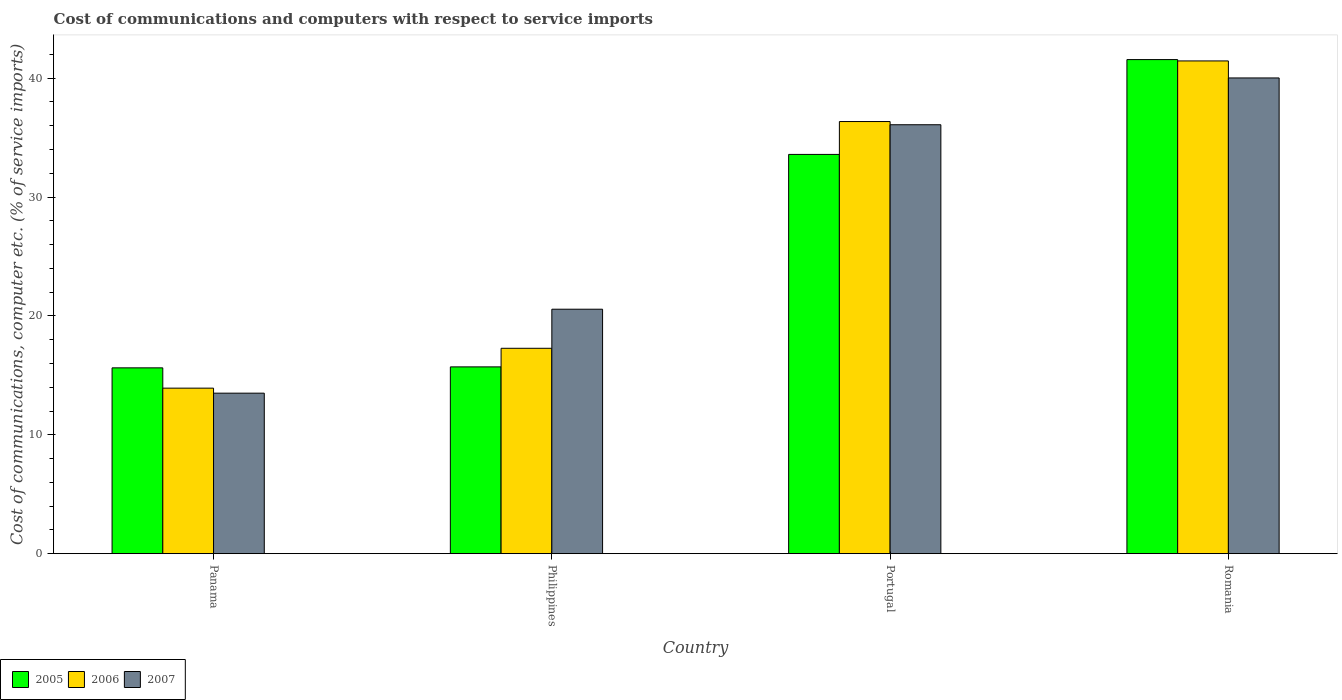How many bars are there on the 4th tick from the left?
Keep it short and to the point. 3. How many bars are there on the 4th tick from the right?
Offer a very short reply. 3. What is the label of the 4th group of bars from the left?
Offer a terse response. Romania. In how many cases, is the number of bars for a given country not equal to the number of legend labels?
Give a very brief answer. 0. What is the cost of communications and computers in 2006 in Philippines?
Your response must be concise. 17.28. Across all countries, what is the maximum cost of communications and computers in 2005?
Provide a short and direct response. 41.57. Across all countries, what is the minimum cost of communications and computers in 2007?
Your answer should be very brief. 13.5. In which country was the cost of communications and computers in 2007 maximum?
Ensure brevity in your answer.  Romania. In which country was the cost of communications and computers in 2007 minimum?
Provide a succinct answer. Panama. What is the total cost of communications and computers in 2006 in the graph?
Keep it short and to the point. 109.01. What is the difference between the cost of communications and computers in 2007 in Philippines and that in Portugal?
Give a very brief answer. -15.52. What is the difference between the cost of communications and computers in 2006 in Panama and the cost of communications and computers in 2007 in Portugal?
Your answer should be very brief. -22.16. What is the average cost of communications and computers in 2007 per country?
Provide a short and direct response. 27.54. What is the difference between the cost of communications and computers of/in 2005 and cost of communications and computers of/in 2007 in Philippines?
Your response must be concise. -4.85. In how many countries, is the cost of communications and computers in 2005 greater than 32 %?
Give a very brief answer. 2. What is the ratio of the cost of communications and computers in 2006 in Philippines to that in Portugal?
Give a very brief answer. 0.48. Is the cost of communications and computers in 2005 in Panama less than that in Philippines?
Give a very brief answer. Yes. What is the difference between the highest and the second highest cost of communications and computers in 2006?
Your answer should be very brief. 5.1. What is the difference between the highest and the lowest cost of communications and computers in 2005?
Give a very brief answer. 25.93. In how many countries, is the cost of communications and computers in 2007 greater than the average cost of communications and computers in 2007 taken over all countries?
Your answer should be very brief. 2. Is the sum of the cost of communications and computers in 2006 in Panama and Portugal greater than the maximum cost of communications and computers in 2005 across all countries?
Your response must be concise. Yes. What does the 2nd bar from the right in Philippines represents?
Offer a terse response. 2006. What is the difference between two consecutive major ticks on the Y-axis?
Provide a succinct answer. 10. Are the values on the major ticks of Y-axis written in scientific E-notation?
Make the answer very short. No. Does the graph contain any zero values?
Make the answer very short. No. Where does the legend appear in the graph?
Your answer should be compact. Bottom left. How many legend labels are there?
Provide a short and direct response. 3. What is the title of the graph?
Ensure brevity in your answer.  Cost of communications and computers with respect to service imports. What is the label or title of the Y-axis?
Your answer should be compact. Cost of communications, computer etc. (% of service imports). What is the Cost of communications, computer etc. (% of service imports) of 2005 in Panama?
Provide a short and direct response. 15.63. What is the Cost of communications, computer etc. (% of service imports) of 2006 in Panama?
Offer a terse response. 13.92. What is the Cost of communications, computer etc. (% of service imports) of 2007 in Panama?
Make the answer very short. 13.5. What is the Cost of communications, computer etc. (% of service imports) in 2005 in Philippines?
Ensure brevity in your answer.  15.71. What is the Cost of communications, computer etc. (% of service imports) in 2006 in Philippines?
Your answer should be very brief. 17.28. What is the Cost of communications, computer etc. (% of service imports) of 2007 in Philippines?
Make the answer very short. 20.57. What is the Cost of communications, computer etc. (% of service imports) of 2005 in Portugal?
Ensure brevity in your answer.  33.59. What is the Cost of communications, computer etc. (% of service imports) of 2006 in Portugal?
Provide a short and direct response. 36.35. What is the Cost of communications, computer etc. (% of service imports) in 2007 in Portugal?
Keep it short and to the point. 36.08. What is the Cost of communications, computer etc. (% of service imports) in 2005 in Romania?
Give a very brief answer. 41.57. What is the Cost of communications, computer etc. (% of service imports) of 2006 in Romania?
Provide a short and direct response. 41.45. What is the Cost of communications, computer etc. (% of service imports) of 2007 in Romania?
Provide a succinct answer. 40.02. Across all countries, what is the maximum Cost of communications, computer etc. (% of service imports) of 2005?
Provide a succinct answer. 41.57. Across all countries, what is the maximum Cost of communications, computer etc. (% of service imports) of 2006?
Provide a short and direct response. 41.45. Across all countries, what is the maximum Cost of communications, computer etc. (% of service imports) of 2007?
Give a very brief answer. 40.02. Across all countries, what is the minimum Cost of communications, computer etc. (% of service imports) of 2005?
Your response must be concise. 15.63. Across all countries, what is the minimum Cost of communications, computer etc. (% of service imports) in 2006?
Provide a short and direct response. 13.92. Across all countries, what is the minimum Cost of communications, computer etc. (% of service imports) of 2007?
Keep it short and to the point. 13.5. What is the total Cost of communications, computer etc. (% of service imports) in 2005 in the graph?
Keep it short and to the point. 106.5. What is the total Cost of communications, computer etc. (% of service imports) of 2006 in the graph?
Give a very brief answer. 109.01. What is the total Cost of communications, computer etc. (% of service imports) in 2007 in the graph?
Offer a very short reply. 110.17. What is the difference between the Cost of communications, computer etc. (% of service imports) in 2005 in Panama and that in Philippines?
Your answer should be very brief. -0.08. What is the difference between the Cost of communications, computer etc. (% of service imports) in 2006 in Panama and that in Philippines?
Ensure brevity in your answer.  -3.35. What is the difference between the Cost of communications, computer etc. (% of service imports) of 2007 in Panama and that in Philippines?
Your answer should be compact. -7.06. What is the difference between the Cost of communications, computer etc. (% of service imports) in 2005 in Panama and that in Portugal?
Give a very brief answer. -17.96. What is the difference between the Cost of communications, computer etc. (% of service imports) of 2006 in Panama and that in Portugal?
Your answer should be very brief. -22.43. What is the difference between the Cost of communications, computer etc. (% of service imports) of 2007 in Panama and that in Portugal?
Your answer should be compact. -22.58. What is the difference between the Cost of communications, computer etc. (% of service imports) in 2005 in Panama and that in Romania?
Your answer should be compact. -25.93. What is the difference between the Cost of communications, computer etc. (% of service imports) of 2006 in Panama and that in Romania?
Provide a short and direct response. -27.53. What is the difference between the Cost of communications, computer etc. (% of service imports) in 2007 in Panama and that in Romania?
Ensure brevity in your answer.  -26.52. What is the difference between the Cost of communications, computer etc. (% of service imports) of 2005 in Philippines and that in Portugal?
Ensure brevity in your answer.  -17.87. What is the difference between the Cost of communications, computer etc. (% of service imports) of 2006 in Philippines and that in Portugal?
Make the answer very short. -19.08. What is the difference between the Cost of communications, computer etc. (% of service imports) of 2007 in Philippines and that in Portugal?
Provide a succinct answer. -15.52. What is the difference between the Cost of communications, computer etc. (% of service imports) of 2005 in Philippines and that in Romania?
Give a very brief answer. -25.85. What is the difference between the Cost of communications, computer etc. (% of service imports) in 2006 in Philippines and that in Romania?
Your answer should be very brief. -24.18. What is the difference between the Cost of communications, computer etc. (% of service imports) in 2007 in Philippines and that in Romania?
Ensure brevity in your answer.  -19.45. What is the difference between the Cost of communications, computer etc. (% of service imports) in 2005 in Portugal and that in Romania?
Ensure brevity in your answer.  -7.98. What is the difference between the Cost of communications, computer etc. (% of service imports) of 2006 in Portugal and that in Romania?
Provide a short and direct response. -5.1. What is the difference between the Cost of communications, computer etc. (% of service imports) of 2007 in Portugal and that in Romania?
Offer a terse response. -3.94. What is the difference between the Cost of communications, computer etc. (% of service imports) of 2005 in Panama and the Cost of communications, computer etc. (% of service imports) of 2006 in Philippines?
Provide a succinct answer. -1.65. What is the difference between the Cost of communications, computer etc. (% of service imports) in 2005 in Panama and the Cost of communications, computer etc. (% of service imports) in 2007 in Philippines?
Provide a succinct answer. -4.93. What is the difference between the Cost of communications, computer etc. (% of service imports) of 2006 in Panama and the Cost of communications, computer etc. (% of service imports) of 2007 in Philippines?
Provide a succinct answer. -6.64. What is the difference between the Cost of communications, computer etc. (% of service imports) of 2005 in Panama and the Cost of communications, computer etc. (% of service imports) of 2006 in Portugal?
Offer a very short reply. -20.72. What is the difference between the Cost of communications, computer etc. (% of service imports) of 2005 in Panama and the Cost of communications, computer etc. (% of service imports) of 2007 in Portugal?
Your answer should be very brief. -20.45. What is the difference between the Cost of communications, computer etc. (% of service imports) of 2006 in Panama and the Cost of communications, computer etc. (% of service imports) of 2007 in Portugal?
Your response must be concise. -22.16. What is the difference between the Cost of communications, computer etc. (% of service imports) of 2005 in Panama and the Cost of communications, computer etc. (% of service imports) of 2006 in Romania?
Give a very brief answer. -25.82. What is the difference between the Cost of communications, computer etc. (% of service imports) in 2005 in Panama and the Cost of communications, computer etc. (% of service imports) in 2007 in Romania?
Provide a succinct answer. -24.39. What is the difference between the Cost of communications, computer etc. (% of service imports) in 2006 in Panama and the Cost of communications, computer etc. (% of service imports) in 2007 in Romania?
Provide a short and direct response. -26.1. What is the difference between the Cost of communications, computer etc. (% of service imports) of 2005 in Philippines and the Cost of communications, computer etc. (% of service imports) of 2006 in Portugal?
Your answer should be compact. -20.64. What is the difference between the Cost of communications, computer etc. (% of service imports) in 2005 in Philippines and the Cost of communications, computer etc. (% of service imports) in 2007 in Portugal?
Your answer should be very brief. -20.37. What is the difference between the Cost of communications, computer etc. (% of service imports) of 2006 in Philippines and the Cost of communications, computer etc. (% of service imports) of 2007 in Portugal?
Your answer should be very brief. -18.81. What is the difference between the Cost of communications, computer etc. (% of service imports) in 2005 in Philippines and the Cost of communications, computer etc. (% of service imports) in 2006 in Romania?
Give a very brief answer. -25.74. What is the difference between the Cost of communications, computer etc. (% of service imports) in 2005 in Philippines and the Cost of communications, computer etc. (% of service imports) in 2007 in Romania?
Offer a very short reply. -24.31. What is the difference between the Cost of communications, computer etc. (% of service imports) in 2006 in Philippines and the Cost of communications, computer etc. (% of service imports) in 2007 in Romania?
Provide a short and direct response. -22.74. What is the difference between the Cost of communications, computer etc. (% of service imports) of 2005 in Portugal and the Cost of communications, computer etc. (% of service imports) of 2006 in Romania?
Ensure brevity in your answer.  -7.86. What is the difference between the Cost of communications, computer etc. (% of service imports) in 2005 in Portugal and the Cost of communications, computer etc. (% of service imports) in 2007 in Romania?
Offer a terse response. -6.43. What is the difference between the Cost of communications, computer etc. (% of service imports) in 2006 in Portugal and the Cost of communications, computer etc. (% of service imports) in 2007 in Romania?
Offer a terse response. -3.67. What is the average Cost of communications, computer etc. (% of service imports) in 2005 per country?
Offer a very short reply. 26.62. What is the average Cost of communications, computer etc. (% of service imports) of 2006 per country?
Your answer should be very brief. 27.25. What is the average Cost of communications, computer etc. (% of service imports) of 2007 per country?
Make the answer very short. 27.54. What is the difference between the Cost of communications, computer etc. (% of service imports) of 2005 and Cost of communications, computer etc. (% of service imports) of 2006 in Panama?
Your response must be concise. 1.71. What is the difference between the Cost of communications, computer etc. (% of service imports) of 2005 and Cost of communications, computer etc. (% of service imports) of 2007 in Panama?
Your answer should be very brief. 2.13. What is the difference between the Cost of communications, computer etc. (% of service imports) of 2006 and Cost of communications, computer etc. (% of service imports) of 2007 in Panama?
Offer a very short reply. 0.42. What is the difference between the Cost of communications, computer etc. (% of service imports) in 2005 and Cost of communications, computer etc. (% of service imports) in 2006 in Philippines?
Offer a terse response. -1.56. What is the difference between the Cost of communications, computer etc. (% of service imports) in 2005 and Cost of communications, computer etc. (% of service imports) in 2007 in Philippines?
Your response must be concise. -4.85. What is the difference between the Cost of communications, computer etc. (% of service imports) of 2006 and Cost of communications, computer etc. (% of service imports) of 2007 in Philippines?
Your answer should be compact. -3.29. What is the difference between the Cost of communications, computer etc. (% of service imports) of 2005 and Cost of communications, computer etc. (% of service imports) of 2006 in Portugal?
Offer a terse response. -2.77. What is the difference between the Cost of communications, computer etc. (% of service imports) in 2005 and Cost of communications, computer etc. (% of service imports) in 2007 in Portugal?
Give a very brief answer. -2.5. What is the difference between the Cost of communications, computer etc. (% of service imports) in 2006 and Cost of communications, computer etc. (% of service imports) in 2007 in Portugal?
Keep it short and to the point. 0.27. What is the difference between the Cost of communications, computer etc. (% of service imports) of 2005 and Cost of communications, computer etc. (% of service imports) of 2006 in Romania?
Provide a short and direct response. 0.11. What is the difference between the Cost of communications, computer etc. (% of service imports) in 2005 and Cost of communications, computer etc. (% of service imports) in 2007 in Romania?
Your answer should be very brief. 1.55. What is the difference between the Cost of communications, computer etc. (% of service imports) in 2006 and Cost of communications, computer etc. (% of service imports) in 2007 in Romania?
Provide a succinct answer. 1.43. What is the ratio of the Cost of communications, computer etc. (% of service imports) of 2006 in Panama to that in Philippines?
Make the answer very short. 0.81. What is the ratio of the Cost of communications, computer etc. (% of service imports) of 2007 in Panama to that in Philippines?
Your response must be concise. 0.66. What is the ratio of the Cost of communications, computer etc. (% of service imports) in 2005 in Panama to that in Portugal?
Your answer should be compact. 0.47. What is the ratio of the Cost of communications, computer etc. (% of service imports) in 2006 in Panama to that in Portugal?
Your answer should be compact. 0.38. What is the ratio of the Cost of communications, computer etc. (% of service imports) in 2007 in Panama to that in Portugal?
Provide a succinct answer. 0.37. What is the ratio of the Cost of communications, computer etc. (% of service imports) in 2005 in Panama to that in Romania?
Your response must be concise. 0.38. What is the ratio of the Cost of communications, computer etc. (% of service imports) of 2006 in Panama to that in Romania?
Provide a short and direct response. 0.34. What is the ratio of the Cost of communications, computer etc. (% of service imports) of 2007 in Panama to that in Romania?
Ensure brevity in your answer.  0.34. What is the ratio of the Cost of communications, computer etc. (% of service imports) in 2005 in Philippines to that in Portugal?
Offer a terse response. 0.47. What is the ratio of the Cost of communications, computer etc. (% of service imports) in 2006 in Philippines to that in Portugal?
Your answer should be very brief. 0.48. What is the ratio of the Cost of communications, computer etc. (% of service imports) in 2007 in Philippines to that in Portugal?
Keep it short and to the point. 0.57. What is the ratio of the Cost of communications, computer etc. (% of service imports) of 2005 in Philippines to that in Romania?
Make the answer very short. 0.38. What is the ratio of the Cost of communications, computer etc. (% of service imports) of 2006 in Philippines to that in Romania?
Ensure brevity in your answer.  0.42. What is the ratio of the Cost of communications, computer etc. (% of service imports) in 2007 in Philippines to that in Romania?
Offer a very short reply. 0.51. What is the ratio of the Cost of communications, computer etc. (% of service imports) in 2005 in Portugal to that in Romania?
Give a very brief answer. 0.81. What is the ratio of the Cost of communications, computer etc. (% of service imports) in 2006 in Portugal to that in Romania?
Give a very brief answer. 0.88. What is the ratio of the Cost of communications, computer etc. (% of service imports) in 2007 in Portugal to that in Romania?
Ensure brevity in your answer.  0.9. What is the difference between the highest and the second highest Cost of communications, computer etc. (% of service imports) in 2005?
Keep it short and to the point. 7.98. What is the difference between the highest and the second highest Cost of communications, computer etc. (% of service imports) in 2006?
Your response must be concise. 5.1. What is the difference between the highest and the second highest Cost of communications, computer etc. (% of service imports) in 2007?
Give a very brief answer. 3.94. What is the difference between the highest and the lowest Cost of communications, computer etc. (% of service imports) of 2005?
Give a very brief answer. 25.93. What is the difference between the highest and the lowest Cost of communications, computer etc. (% of service imports) in 2006?
Offer a terse response. 27.53. What is the difference between the highest and the lowest Cost of communications, computer etc. (% of service imports) of 2007?
Provide a succinct answer. 26.52. 